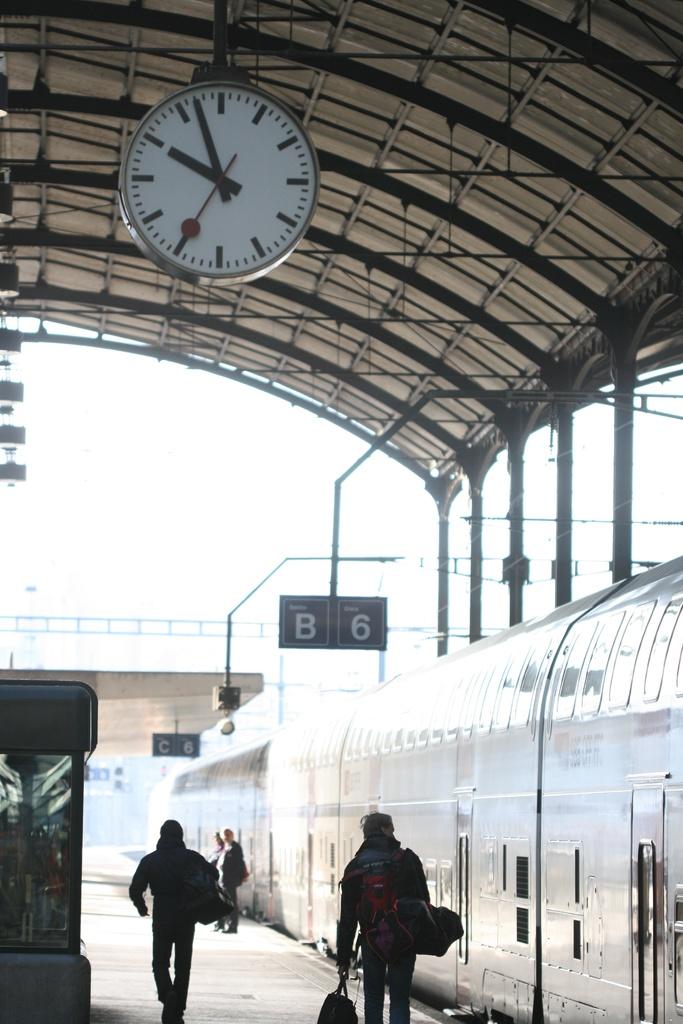What is the time on the clock?
Your answer should be compact. 9:57. What is the platform number on the sign the man with the two bags is walking under?
Give a very brief answer. B6. 